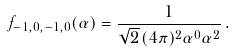Convert formula to latex. <formula><loc_0><loc_0><loc_500><loc_500>f _ { - 1 , 0 , - 1 , 0 } ( \alpha ) = \frac { 1 } { \sqrt { 2 } \, ( 4 \pi ) ^ { 2 } \alpha ^ { 0 } \alpha ^ { 2 } } \, .</formula> 